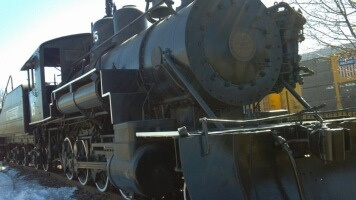Describe the objects in this image and their specific colors. I can see a train in black, lightblue, purple, and darkblue tones in this image. 